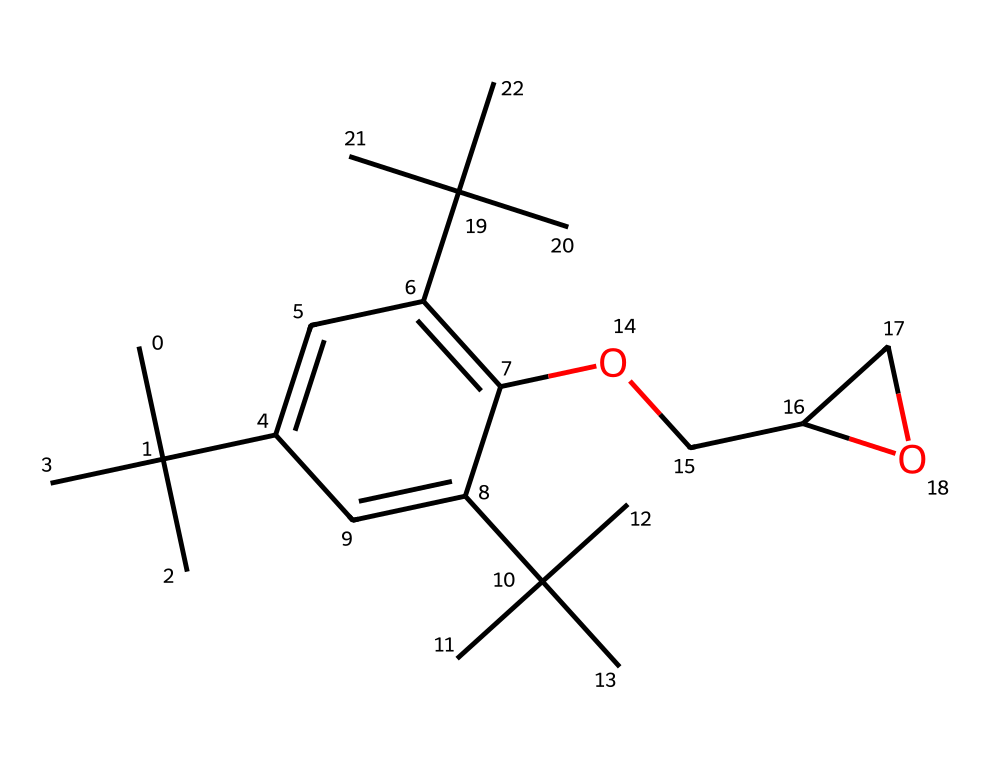What is the total number of carbon atoms in this chemical? By analyzing the SMILES representation, we count the number of 'C' characters present. Each 'C' represents a carbon atom, and after careful counting, we find there are 22 carbon atoms in total.
Answer: 22 How many oxygen atoms are in this chemical? The SMILES contains the letter 'O' which represents oxygen. We can count the occurrences of 'O' in the structure. In this case, there are 2 oxygen atoms present.
Answer: 2 What type of chemical compound is represented by this structure? The presence of multiple carbon chains and the functional group hydroxyl (indicated by 'O') alongside carbon suggests that it belongs to the class of polymers, specifically epoxy resins commonly used in restoration.
Answer: epoxy resin Is this chemical likely to be hazardous? Epoxy resins can have hazardous properties due to their curing agents and potential for release of harmful substances during application. Thus, this chemical can be classified as hazardous in certain conditions.
Answer: yes What functional groups are present in this chemical? In the structure given by the SMILES, the -OH group indicates a hydroxyl functional group, which is characteristic of alcohols and is present in this chemical. This suggests functionalities that may be related to bonding in monument restoration.
Answer: hydroxyl How many double bonds are present in this chemical? By dissecting the SMILES representation, specifically looking for '=' signs indicating double bonds, we find a total of 5 double bonds in the structure.
Answer: 5 What structural feature allows epoxy resins to bond to surfaces? The presence of reactive functional groups such as the epoxide group (noted in the chemical structure) allows for strong bonding to various surfaces when cured, making it effective for restoration purposes.
Answer: epoxide group 